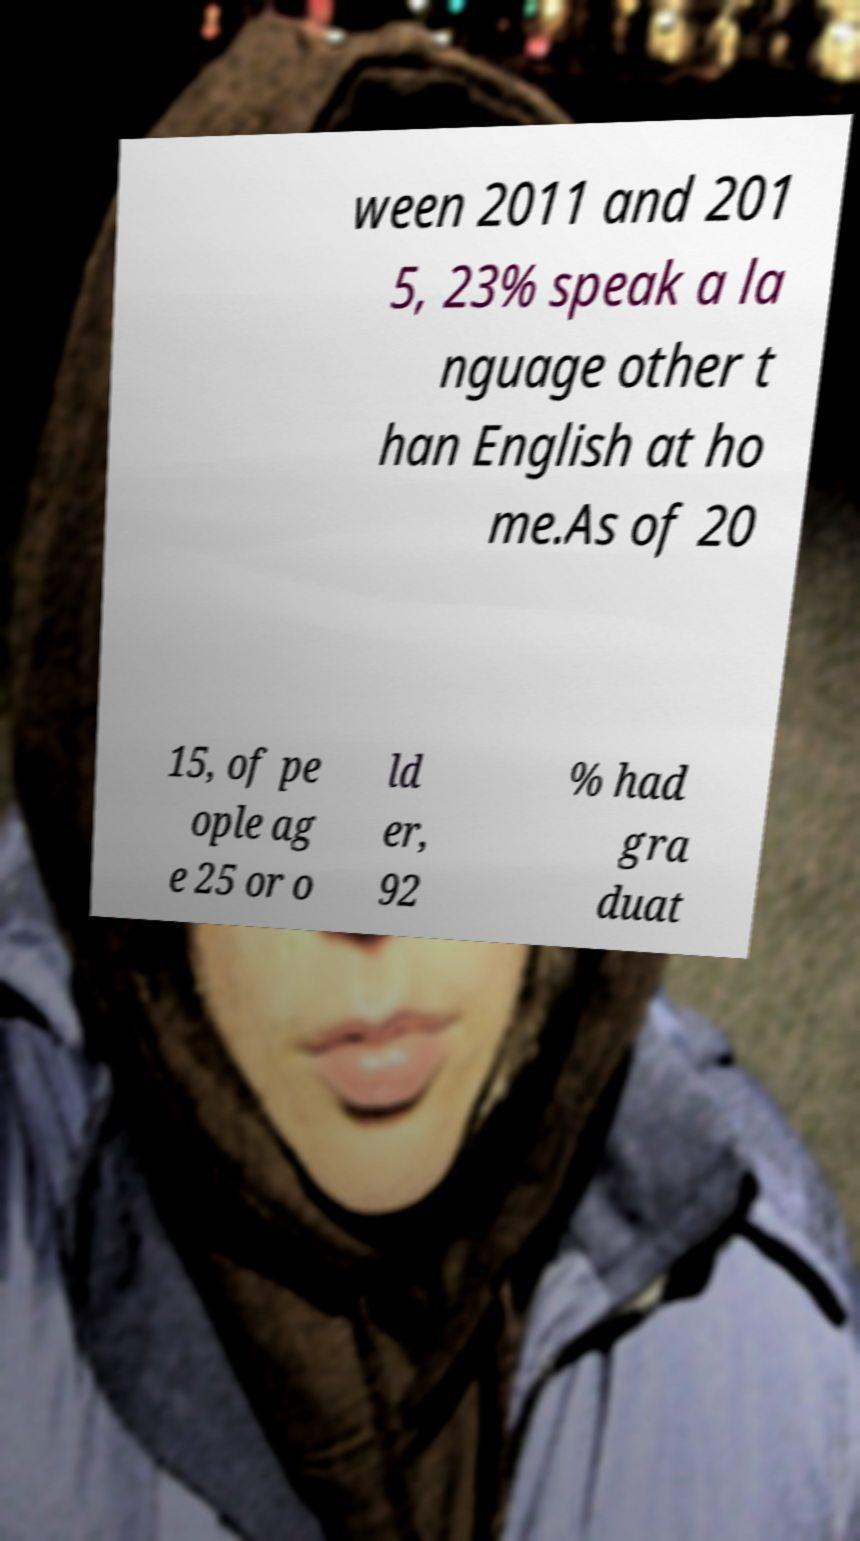Can you read and provide the text displayed in the image?This photo seems to have some interesting text. Can you extract and type it out for me? ween 2011 and 201 5, 23% speak a la nguage other t han English at ho me.As of 20 15, of pe ople ag e 25 or o ld er, 92 % had gra duat 